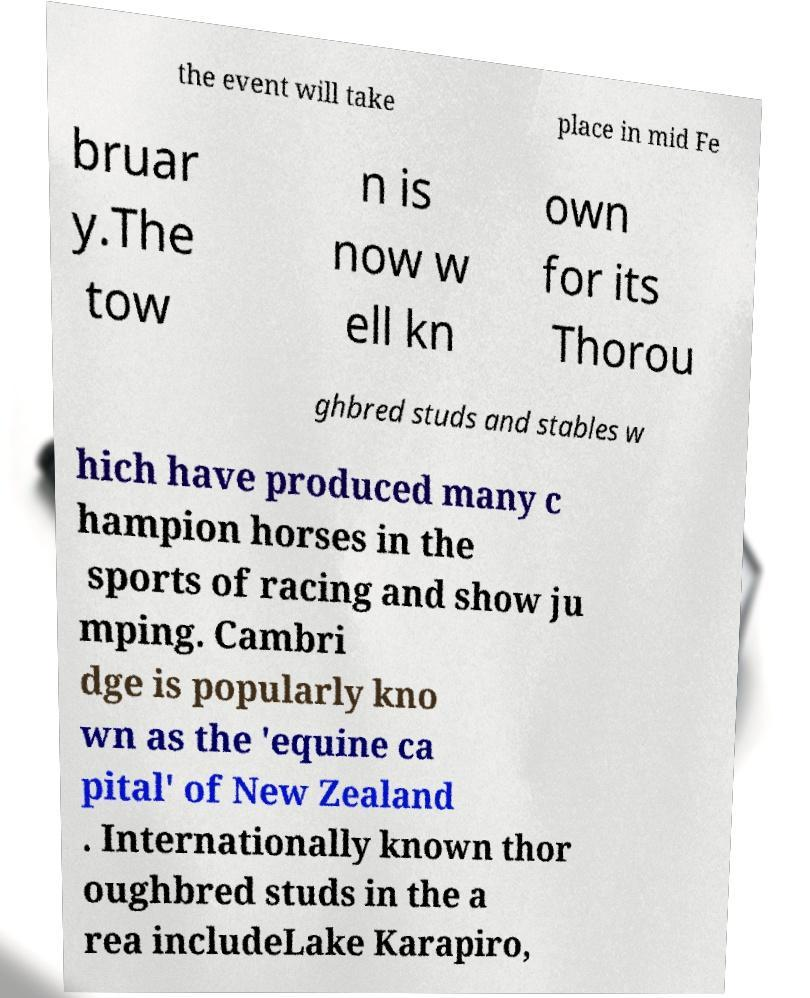Please read and relay the text visible in this image. What does it say? the event will take place in mid Fe bruar y.The tow n is now w ell kn own for its Thorou ghbred studs and stables w hich have produced many c hampion horses in the sports of racing and show ju mping. Cambri dge is popularly kno wn as the 'equine ca pital' of New Zealand . Internationally known thor oughbred studs in the a rea includeLake Karapiro, 